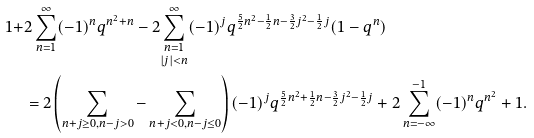<formula> <loc_0><loc_0><loc_500><loc_500>1 + & 2 \sum _ { n = 1 } ^ { \infty } ( - 1 ) ^ { n } q ^ { n ^ { 2 } + n } - 2 \underset { | j | < n } { \sum _ { n = 1 } ^ { \infty } } ( - 1 ) ^ { j } q ^ { \frac { 5 } { 2 } n ^ { 2 } - \frac { 1 } { 2 } n - \frac { 3 } { 2 } j ^ { 2 } - \frac { 1 } { 2 } j } ( 1 - q ^ { n } ) \\ & = 2 \left ( \sum _ { n + j \geq 0 , n - j > 0 } - \sum _ { n + j < 0 , n - j \leq 0 } \right ) ( - 1 ) ^ { j } q ^ { \frac { 5 } { 2 } n ^ { 2 } + \frac { 1 } { 2 } n - \frac { 3 } { 2 } j ^ { 2 } - \frac { 1 } { 2 } j } + 2 \sum _ { n = - \infty } ^ { - 1 } ( - 1 ) ^ { n } q ^ { n ^ { 2 } } + 1 .</formula> 